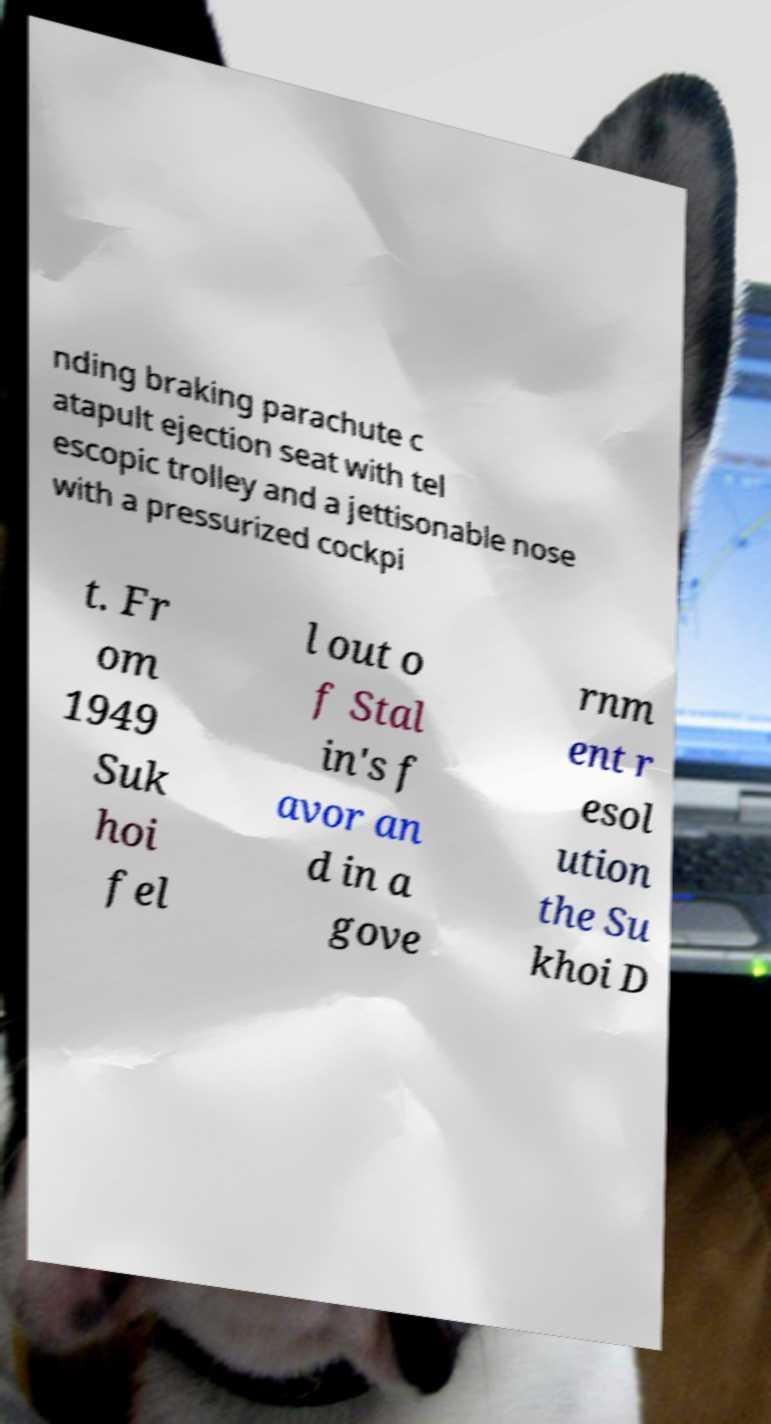I need the written content from this picture converted into text. Can you do that? nding braking parachute c atapult ejection seat with tel escopic trolley and a jettisonable nose with a pressurized cockpi t. Fr om 1949 Suk hoi fel l out o f Stal in's f avor an d in a gove rnm ent r esol ution the Su khoi D 